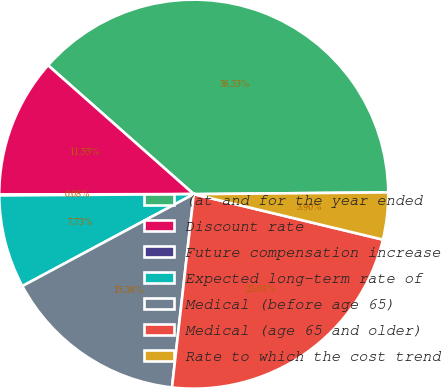<chart> <loc_0><loc_0><loc_500><loc_500><pie_chart><fcel>(at and for the year ended<fcel>Discount rate<fcel>Future compensation increase<fcel>Expected long-term rate of<fcel>Medical (before age 65)<fcel>Medical (age 65 and older)<fcel>Rate to which the cost trend<nl><fcel>38.33%<fcel>11.55%<fcel>0.08%<fcel>7.73%<fcel>15.38%<fcel>23.03%<fcel>3.9%<nl></chart> 